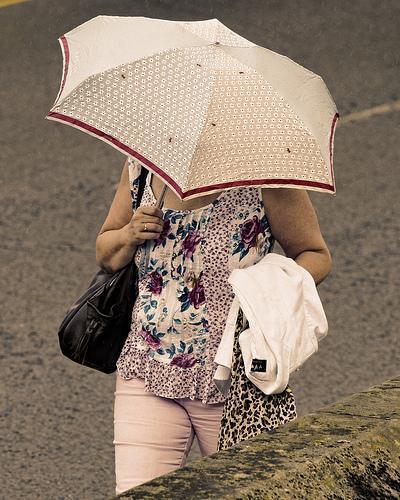How many people are there?
Give a very brief answer. 1. 